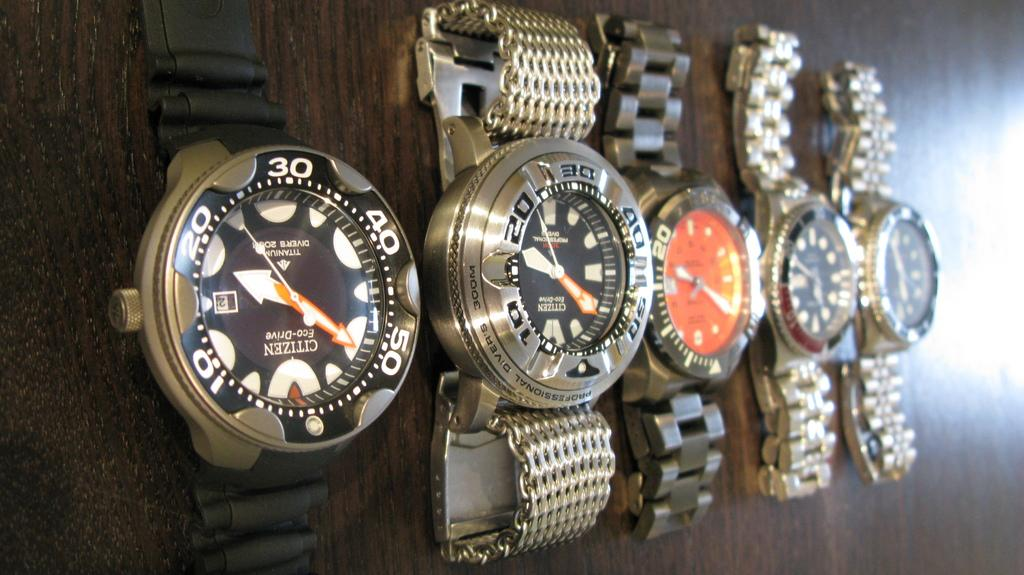<image>
Offer a succinct explanation of the picture presented. A line up of 5 watches Citizen can be seen on the first watch to the left. 